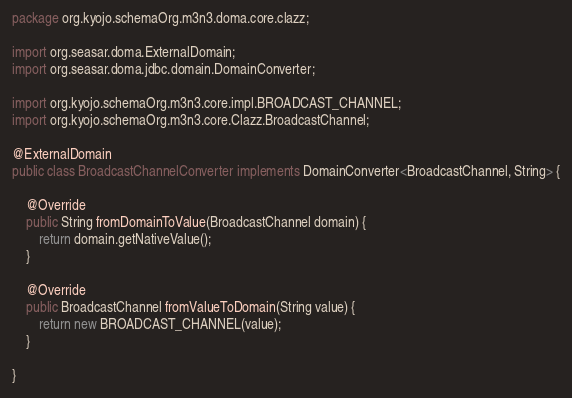<code> <loc_0><loc_0><loc_500><loc_500><_Java_>package org.kyojo.schemaOrg.m3n3.doma.core.clazz;

import org.seasar.doma.ExternalDomain;
import org.seasar.doma.jdbc.domain.DomainConverter;

import org.kyojo.schemaOrg.m3n3.core.impl.BROADCAST_CHANNEL;
import org.kyojo.schemaOrg.m3n3.core.Clazz.BroadcastChannel;

@ExternalDomain
public class BroadcastChannelConverter implements DomainConverter<BroadcastChannel, String> {

	@Override
	public String fromDomainToValue(BroadcastChannel domain) {
		return domain.getNativeValue();
	}

	@Override
	public BroadcastChannel fromValueToDomain(String value) {
		return new BROADCAST_CHANNEL(value);
	}

}
</code> 